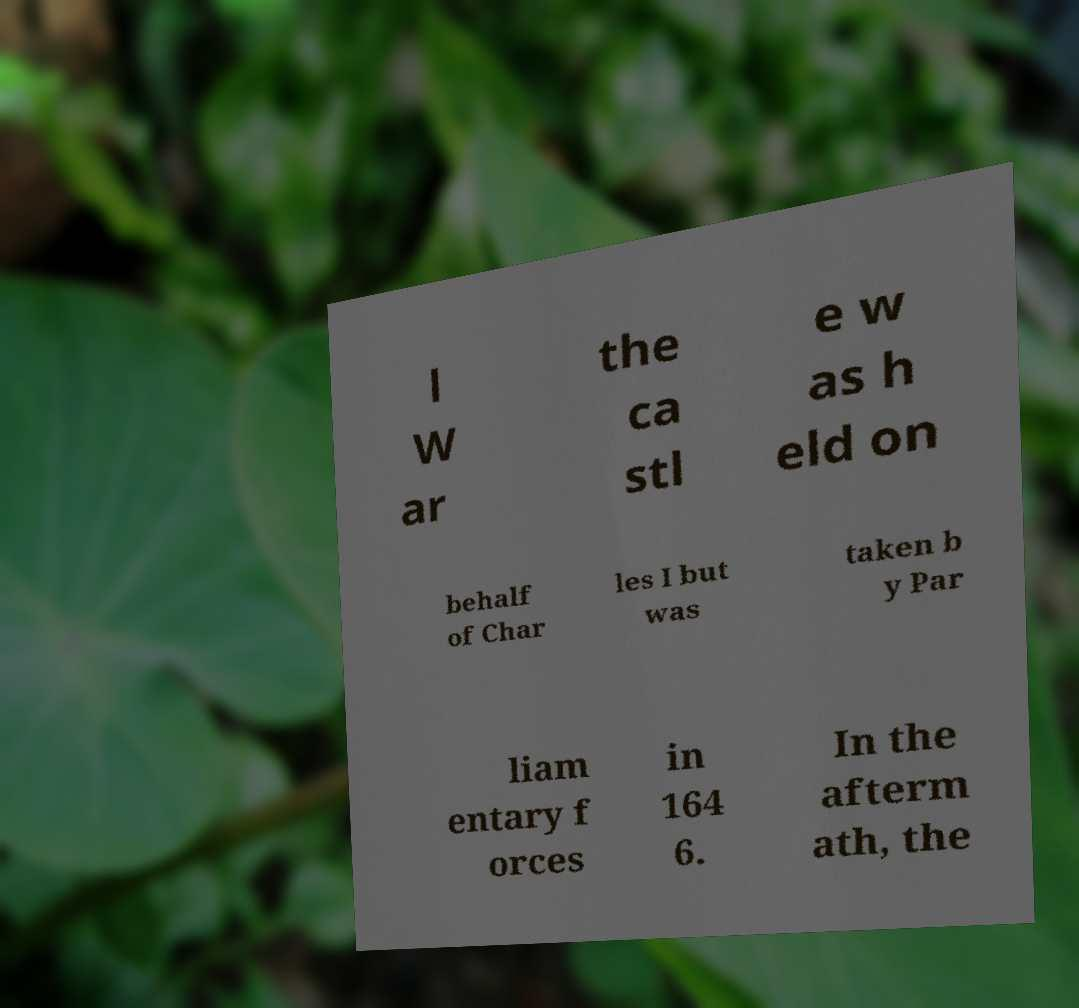Please identify and transcribe the text found in this image. l W ar the ca stl e w as h eld on behalf of Char les I but was taken b y Par liam entary f orces in 164 6. In the afterm ath, the 